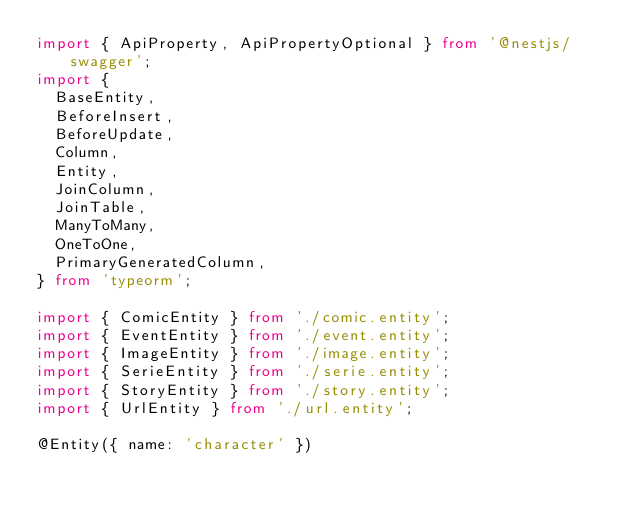<code> <loc_0><loc_0><loc_500><loc_500><_TypeScript_>import { ApiProperty, ApiPropertyOptional } from '@nestjs/swagger';
import {
  BaseEntity,
  BeforeInsert,
  BeforeUpdate,
  Column,
  Entity,
  JoinColumn,
  JoinTable,
  ManyToMany,
  OneToOne,
  PrimaryGeneratedColumn,
} from 'typeorm';

import { ComicEntity } from './comic.entity';
import { EventEntity } from './event.entity';
import { ImageEntity } from './image.entity';
import { SerieEntity } from './serie.entity';
import { StoryEntity } from './story.entity';
import { UrlEntity } from './url.entity';

@Entity({ name: 'character' })</code> 